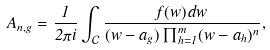<formula> <loc_0><loc_0><loc_500><loc_500>A _ { n , g } = \frac { 1 } { 2 \pi i } \int _ { \mathcal { C } } \frac { f ( w ) \, d w } { ( w - a _ { g } ) \prod _ { h = 1 } ^ { m } ( w - a _ { h } ) ^ { n } } ,</formula> 